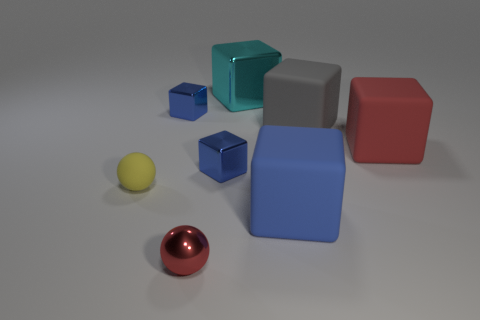There is a rubber thing right of the gray cube; is it the same color as the tiny cube that is in front of the gray object?
Ensure brevity in your answer.  No. Are there fewer blue objects that are in front of the red matte object than gray rubber cubes that are behind the gray block?
Give a very brief answer. No. What shape is the red object that is on the left side of the cyan shiny block?
Provide a succinct answer. Sphere. There is a cube that is the same color as the tiny metal ball; what material is it?
Keep it short and to the point. Rubber. What number of other objects are the same material as the gray thing?
Your answer should be very brief. 3. Is the shape of the red shiny thing the same as the red object that is to the right of the big blue matte block?
Your answer should be compact. No. What shape is the cyan object that is made of the same material as the red ball?
Make the answer very short. Cube. Are there more yellow rubber spheres behind the large red thing than tiny blue shiny blocks in front of the red sphere?
Your response must be concise. No. What number of things are big matte cylinders or big cyan things?
Make the answer very short. 1. How many other objects are the same color as the small metallic sphere?
Give a very brief answer. 1. 